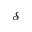Convert formula to latex. <formula><loc_0><loc_0><loc_500><loc_500>\mathcal { S }</formula> 